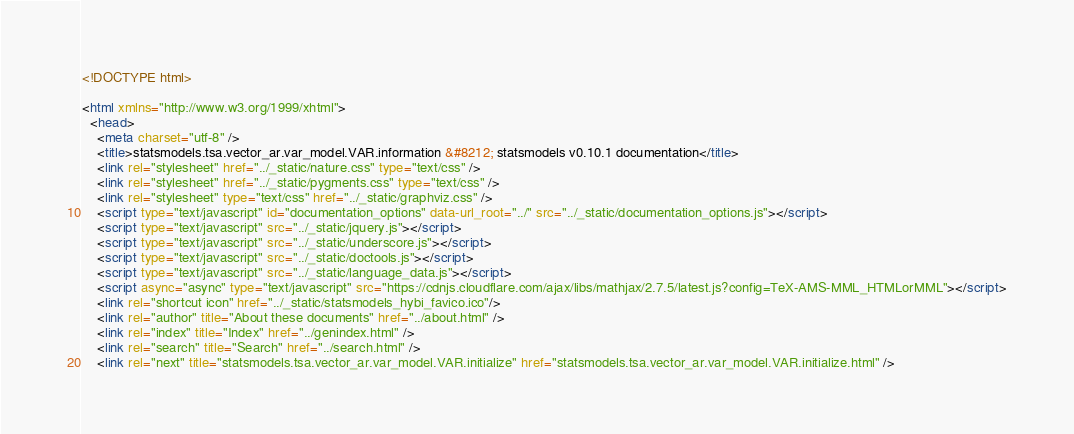<code> <loc_0><loc_0><loc_500><loc_500><_HTML_>

<!DOCTYPE html>

<html xmlns="http://www.w3.org/1999/xhtml">
  <head>
    <meta charset="utf-8" />
    <title>statsmodels.tsa.vector_ar.var_model.VAR.information &#8212; statsmodels v0.10.1 documentation</title>
    <link rel="stylesheet" href="../_static/nature.css" type="text/css" />
    <link rel="stylesheet" href="../_static/pygments.css" type="text/css" />
    <link rel="stylesheet" type="text/css" href="../_static/graphviz.css" />
    <script type="text/javascript" id="documentation_options" data-url_root="../" src="../_static/documentation_options.js"></script>
    <script type="text/javascript" src="../_static/jquery.js"></script>
    <script type="text/javascript" src="../_static/underscore.js"></script>
    <script type="text/javascript" src="../_static/doctools.js"></script>
    <script type="text/javascript" src="../_static/language_data.js"></script>
    <script async="async" type="text/javascript" src="https://cdnjs.cloudflare.com/ajax/libs/mathjax/2.7.5/latest.js?config=TeX-AMS-MML_HTMLorMML"></script>
    <link rel="shortcut icon" href="../_static/statsmodels_hybi_favico.ico"/>
    <link rel="author" title="About these documents" href="../about.html" />
    <link rel="index" title="Index" href="../genindex.html" />
    <link rel="search" title="Search" href="../search.html" />
    <link rel="next" title="statsmodels.tsa.vector_ar.var_model.VAR.initialize" href="statsmodels.tsa.vector_ar.var_model.VAR.initialize.html" /></code> 